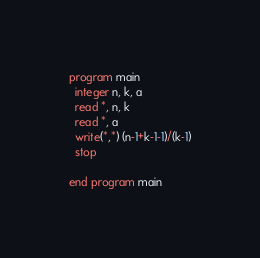Convert code to text. <code><loc_0><loc_0><loc_500><loc_500><_FORTRAN_>program main
  integer n, k, a 
  read *, n, k
  read *, a
  write(*,*) (n-1+k-1-1)/(k-1)
  stop

end program main
</code> 